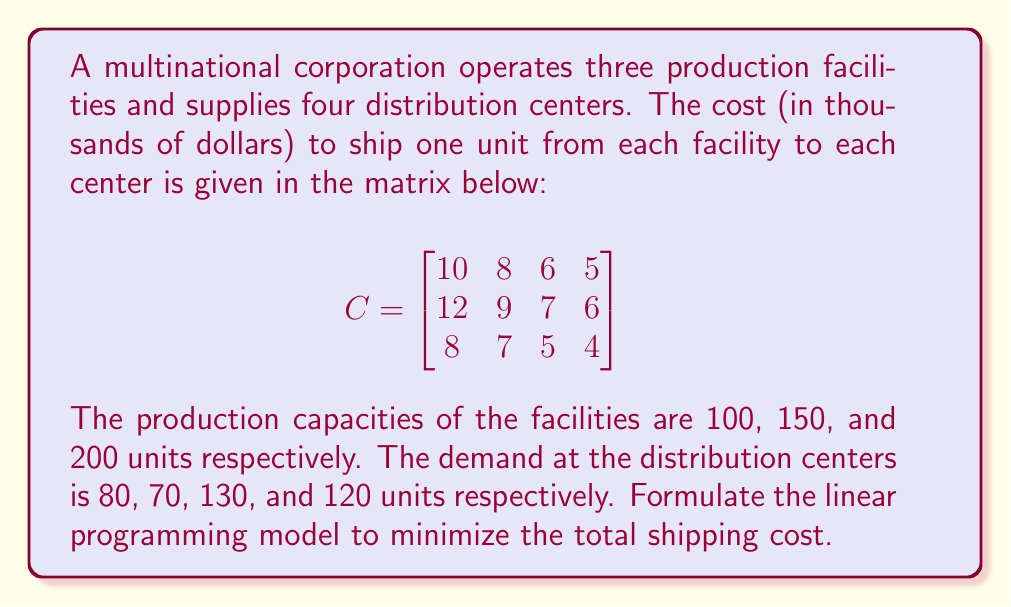Could you help me with this problem? To formulate the linear programming model, we need to define the decision variables, objective function, and constraints.

Step 1: Define decision variables
Let $x_{ij}$ be the number of units shipped from facility $i$ to distribution center $j$.

Step 2: Formulate the objective function
The objective is to minimize the total shipping cost. This can be expressed as:

$$\text{Minimize } Z = \sum_{i=1}^3\sum_{j=1}^4 c_{ij}x_{ij}$$

Where $c_{ij}$ represents the cost of shipping one unit from facility $i$ to distribution center $j$.

Step 3: Formulate the constraints

Supply constraints (for each facility):
$$\sum_{j=1}^4 x_{1j} \leq 100$$
$$\sum_{j=1}^4 x_{2j} \leq 150$$
$$\sum_{j=1}^4 x_{3j} \leq 200$$

Demand constraints (for each distribution center):
$$\sum_{i=1}^3 x_{i1} = 80$$
$$\sum_{i=1}^3 x_{i2} = 70$$
$$\sum_{i=1}^3 x_{i3} = 130$$
$$\sum_{i=1}^3 x_{i4} = 120$$

Non-negativity constraints:
$$x_{ij} \geq 0 \text{ for all } i \text{ and } j$$

Step 4: Write the complete linear programming model

Minimize:
$$Z = 10x_{11} + 8x_{12} + 6x_{13} + 5x_{14} + 12x_{21} + 9x_{22} + 7x_{23} + 6x_{24} + 8x_{31} + 7x_{32} + 5x_{33} + 4x_{34}$$

Subject to:
$$x_{11} + x_{12} + x_{13} + x_{14} \leq 100$$
$$x_{21} + x_{22} + x_{23} + x_{24} \leq 150$$
$$x_{31} + x_{32} + x_{33} + x_{34} \leq 200$$
$$x_{11} + x_{21} + x_{31} = 80$$
$$x_{12} + x_{22} + x_{32} = 70$$
$$x_{13} + x_{23} + x_{33} = 130$$
$$x_{14} + x_{24} + x_{34} = 120$$
$$x_{ij} \geq 0 \text{ for all } i \text{ and } j$$
Answer: Minimize: $Z = 10x_{11} + 8x_{12} + 6x_{13} + 5x_{14} + 12x_{21} + 9x_{22} + 7x_{23} + 6x_{24} + 8x_{31} + 7x_{32} + 5x_{33} + 4x_{34}$
Subject to: Supply, demand, and non-negativity constraints. 